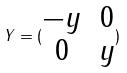<formula> <loc_0><loc_0><loc_500><loc_500>Y = ( \begin{matrix} - y & 0 \\ 0 & y \end{matrix} )</formula> 